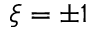<formula> <loc_0><loc_0><loc_500><loc_500>\xi = \pm 1</formula> 